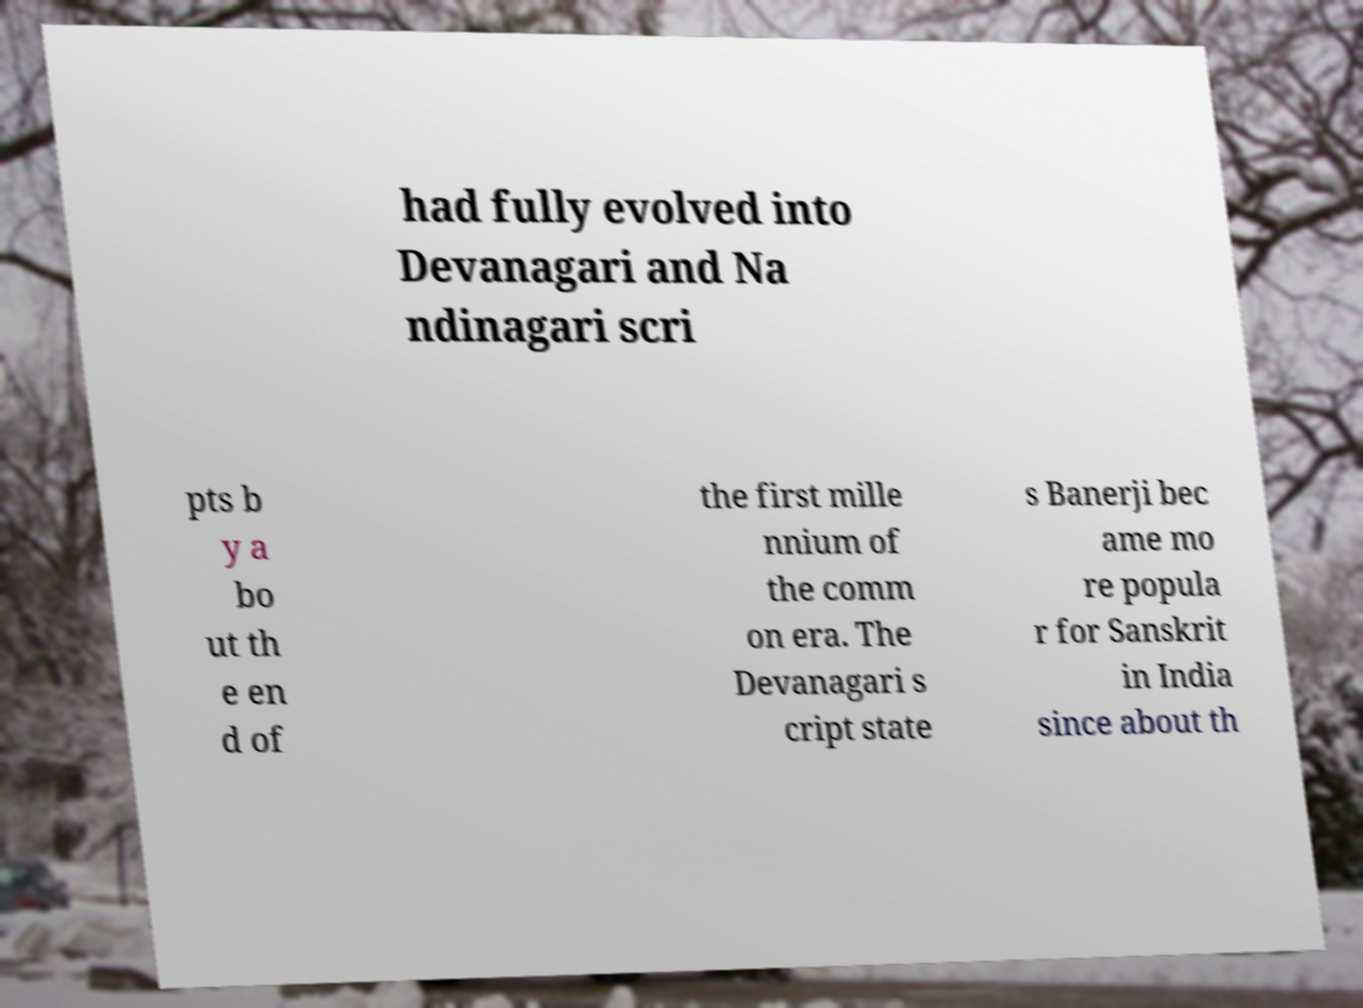There's text embedded in this image that I need extracted. Can you transcribe it verbatim? had fully evolved into Devanagari and Na ndinagari scri pts b y a bo ut th e en d of the first mille nnium of the comm on era. The Devanagari s cript state s Banerji bec ame mo re popula r for Sanskrit in India since about th 